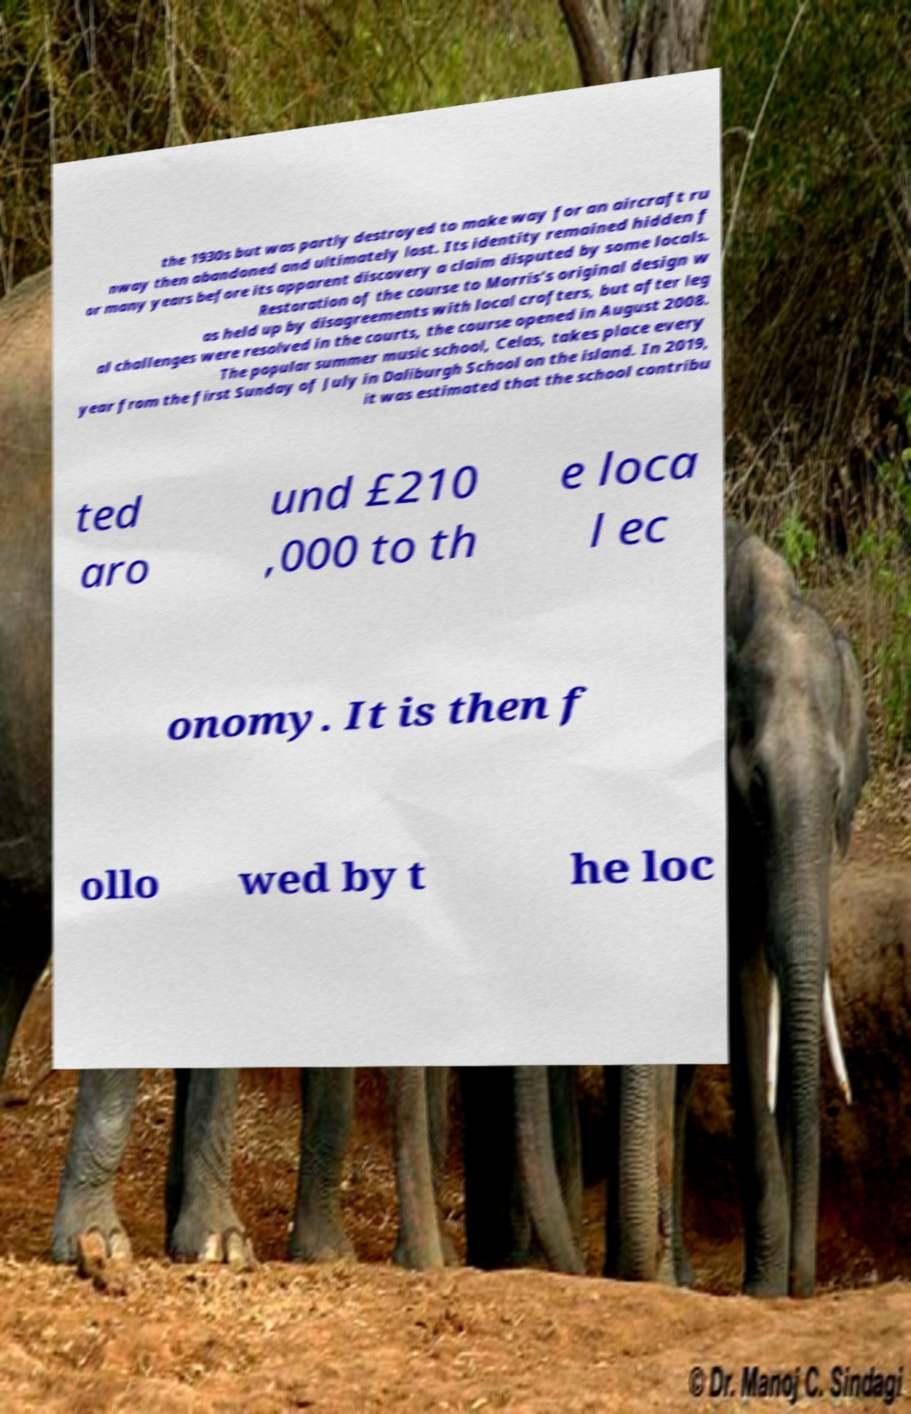For documentation purposes, I need the text within this image transcribed. Could you provide that? the 1930s but was partly destroyed to make way for an aircraft ru nway then abandoned and ultimately lost. Its identity remained hidden f or many years before its apparent discovery a claim disputed by some locals. Restoration of the course to Morris's original design w as held up by disagreements with local crofters, but after leg al challenges were resolved in the courts, the course opened in August 2008. The popular summer music school, Celas, takes place every year from the first Sunday of July in Daliburgh School on the island. In 2019, it was estimated that the school contribu ted aro und £210 ,000 to th e loca l ec onomy. It is then f ollo wed by t he loc 